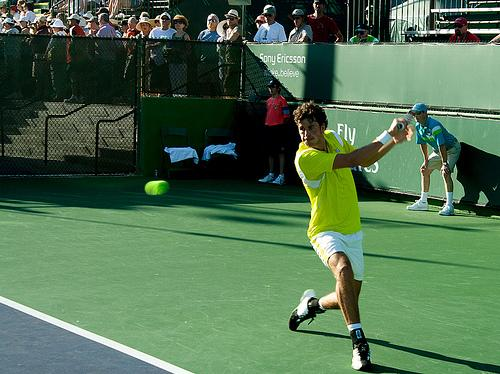Provide a concise explanation of the main subject's action and appearance in the image. A man wearing a yellow shirt and white shorts is seen preparing to strike a tennis ball with his racket. Describe the primary person in the image and their current activity. A man dressed in a yellow shirt and white shorts is playing tennis and about to hit a ball with his racket. Write a short statement about the main subject's appearance and action in the photograph. A tennis player, sporting a yellow shirt and white shorts, is getting ready to strike an airborne ball with his racket. Briefly talk about the key object in the scene and what they are attempting to do. A male tennis athlete, adorned in a yellow shirt and white shorts, is preparing to make contact with a ball. Explain the central subject in the photo and their present undertaking. A tennis player in yellow and white attire is in action, readying himself for a shot at the ball in the air. Detail the primary figure in the picture and state what they are engaged in doing. An adult male tennis player, attired in a yellow shirt and white shorts, is set to hit an airborne ball with his racket. Provide a description of the primary object and their activity in the scene. An adult male tennis player wearing a yellow shirt and white shorts is preparing to hit a ball in the air with his racket. Give a succinct summary of the principal individual's appearance and what they are engaged in. A male tennis player in a yellow shirt and white shorts is preparing to hit a ball that is in motion. Mention the central figure in the image and briefly describe their ongoing action. A man playing tennis, wearing white shorts and a yellow shirt, is about to hit a tennis ball with his racket. Narrate the appearance and ongoing action of the main object found in the image. A man donning a yellow shirt and white shorts is actively playing tennis, about to hit a ball in mid-flight. 